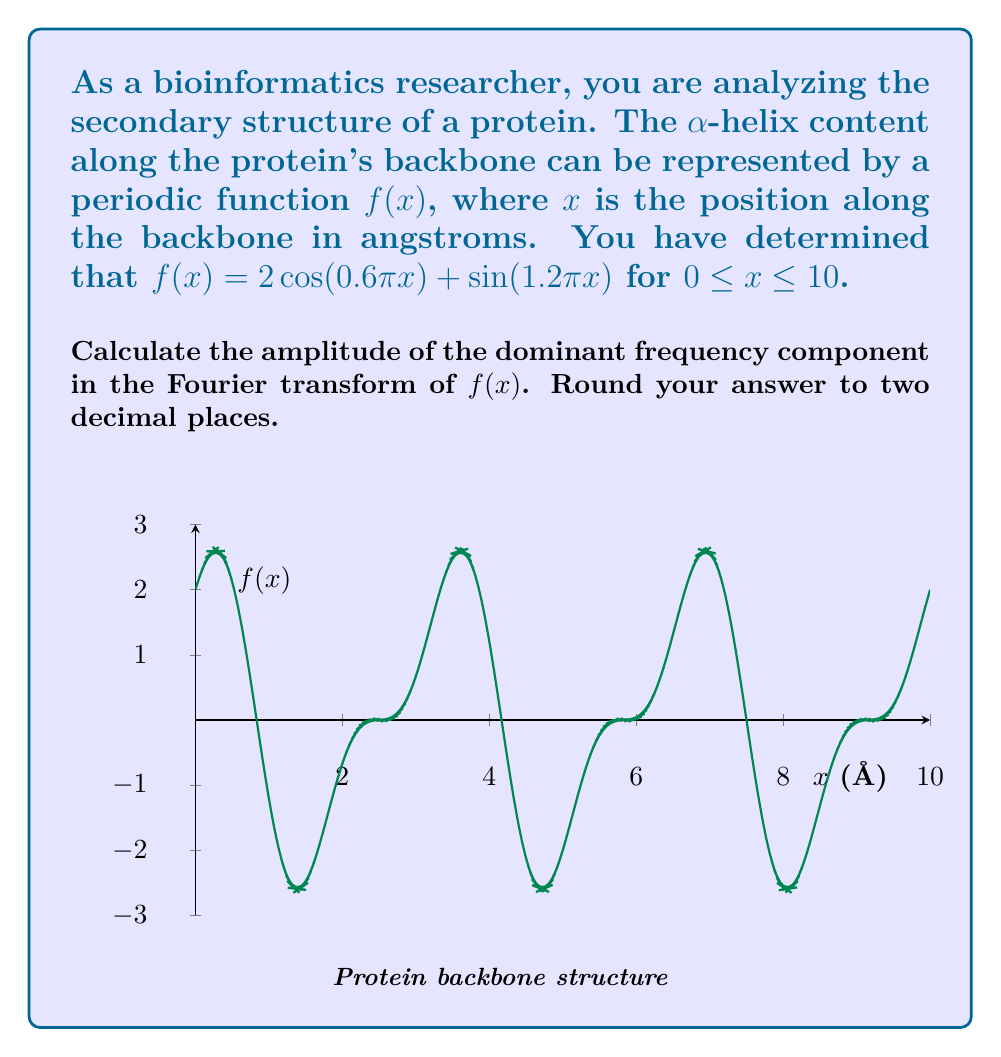Solve this math problem. To solve this problem, we'll follow these steps:

1) The Fourier transform of $f(x)$ is given by:

   $$F(\omega) = \int_{-\infty}^{\infty} f(x)e^{-i\omega x}dx$$

2) For our periodic function on a finite interval, we can use the Fourier series coefficients:

   $$c_n = \frac{1}{L}\int_{0}^{L} f(x)e^{-i\frac{2\pi nx}{L}}dx$$

   where $L = 10$ is the length of our interval.

3) Our function $f(x) = 2\cos(0.6\pi x) + \sin(1.2\pi x)$ can be rewritten as:

   $$f(x) = \cos(0.6\pi x) + \cos(0.6\pi x) + \frac{1}{2i}(e^{i1.2\pi x} - e^{-i1.2\pi x})$$

4) Comparing with the general form of Fourier series, we can identify the frequency components:

   $\omega_1 = 0.6\pi$ with amplitude $2$
   $\omega_2 = 1.2\pi$ with amplitude $1$

5) The dominant frequency component is the one with the larger amplitude, which is $\omega_1 = 0.6\pi$ with amplitude $2$.
Answer: 2.00 